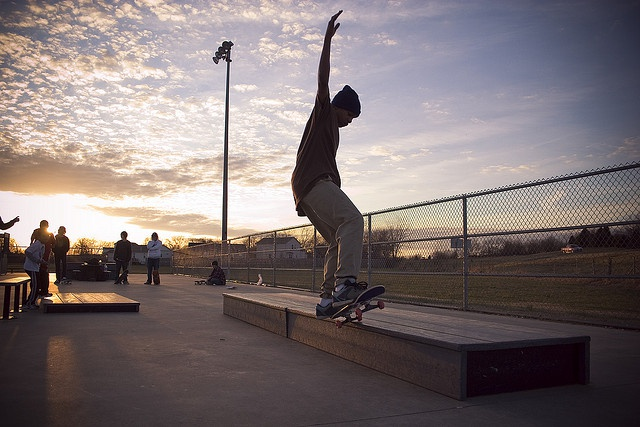Describe the objects in this image and their specific colors. I can see people in black, lightgray, and gray tones, people in black, maroon, and gray tones, skateboard in black and gray tones, people in black and gray tones, and bench in black, maroon, tan, and khaki tones in this image. 